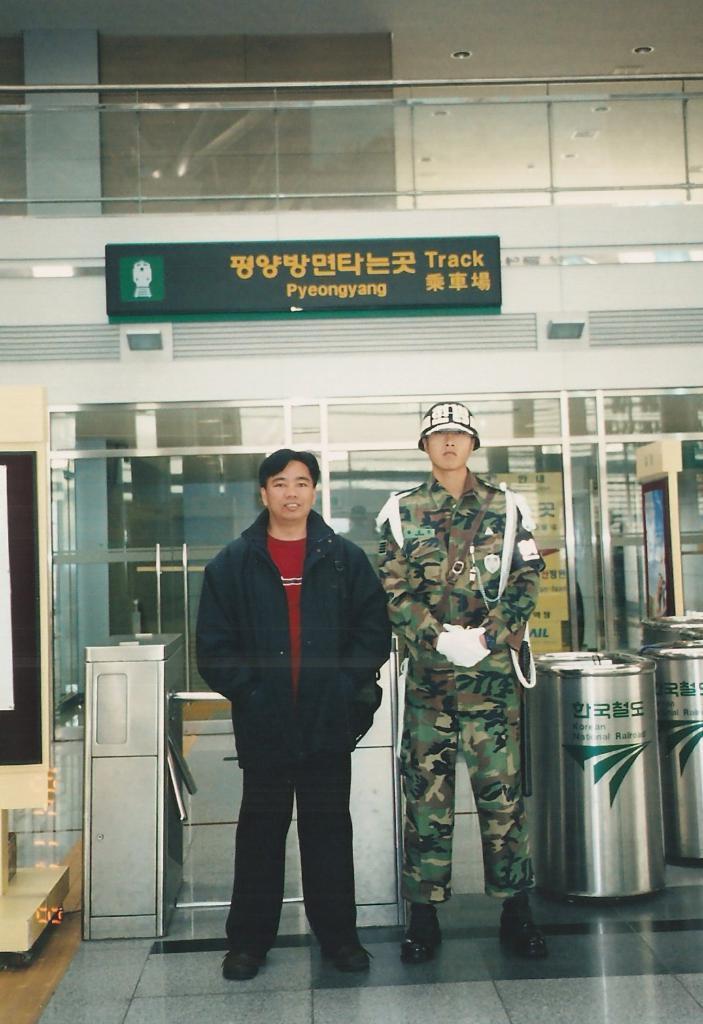How would you summarize this image in a sentence or two? In this image I can see two persons standing. The person at right wearing military uniform and the person at left wearing black and red color dress, background I can see few glass doors and I can see a black color board attached to the wall. 